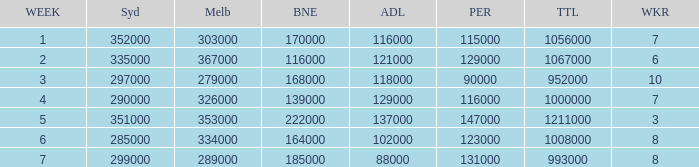Can you parse all the data within this table? {'header': ['WEEK', 'Syd', 'Melb', 'BNE', 'ADL', 'PER', 'TTL', 'WKR'], 'rows': [['1', '352000', '303000', '170000', '116000', '115000', '1056000', '7'], ['2', '335000', '367000', '116000', '121000', '129000', '1067000', '6'], ['3', '297000', '279000', '168000', '118000', '90000', '952000', '10'], ['4', '290000', '326000', '139000', '129000', '116000', '1000000', '7'], ['5', '351000', '353000', '222000', '137000', '147000', '1211000', '3'], ['6', '285000', '334000', '164000', '102000', '123000', '1008000', '8'], ['7', '299000', '289000', '185000', '88000', '131000', '993000', '8']]} What is the highest number of Brisbane viewers? 222000.0. 